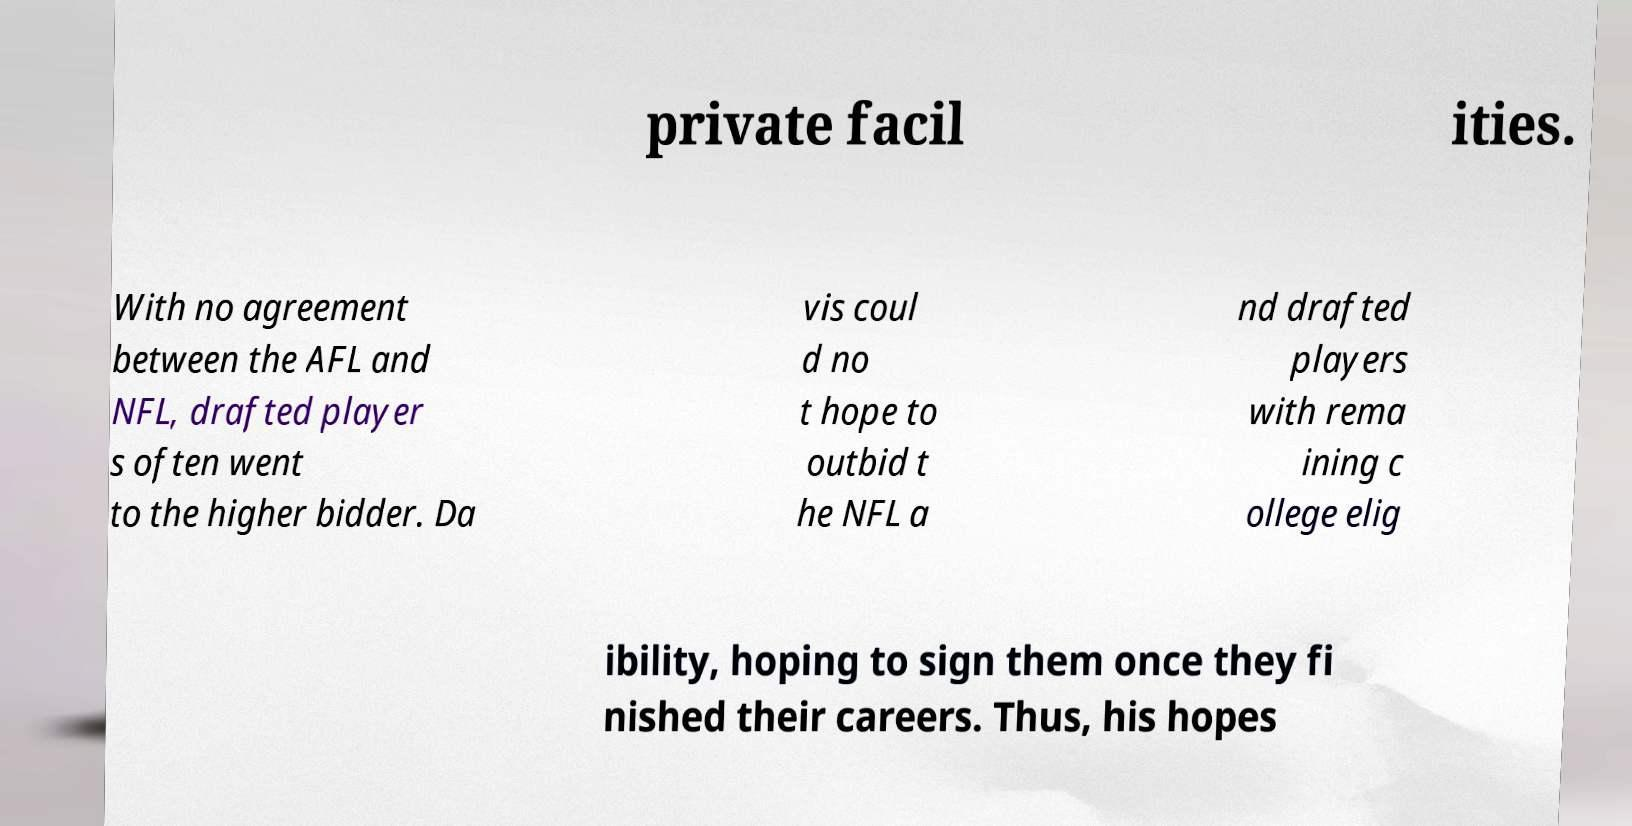Could you extract and type out the text from this image? private facil ities. With no agreement between the AFL and NFL, drafted player s often went to the higher bidder. Da vis coul d no t hope to outbid t he NFL a nd drafted players with rema ining c ollege elig ibility, hoping to sign them once they fi nished their careers. Thus, his hopes 